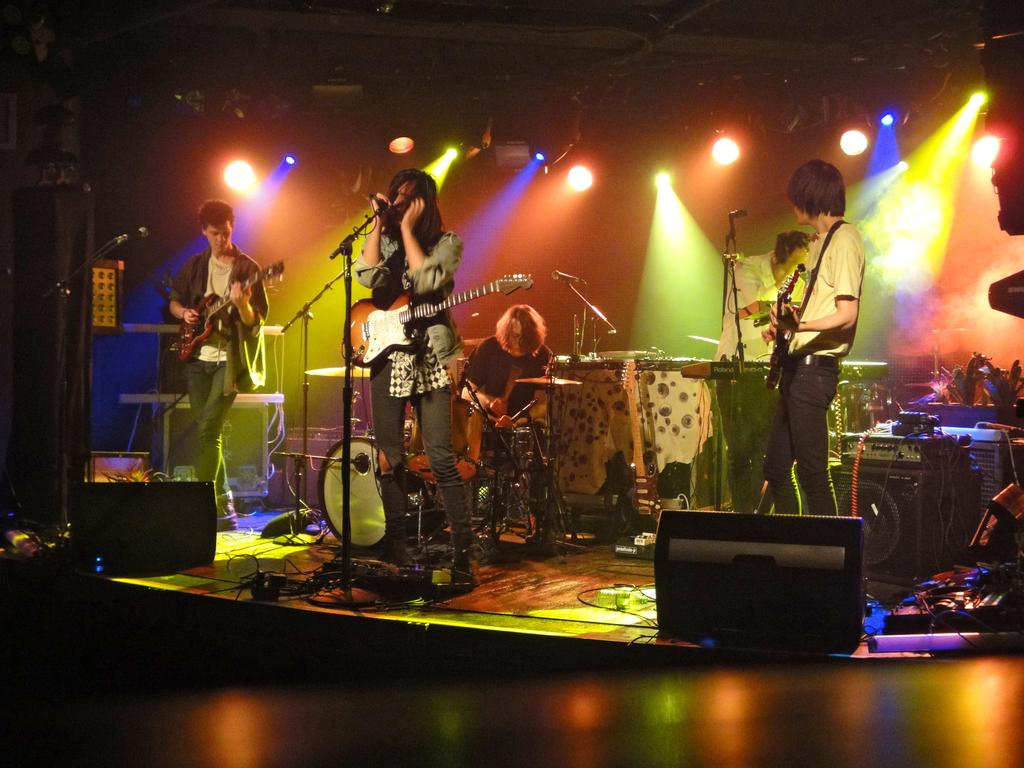What is happening in the image? There is a group of people in the image, and they are playing musical instruments. What is the role of the person in front of the microphone? One person is singing in front of a microphone. How many lizards can be seen in the scene? There are no lizards present in the image. What type of goat is featured in the background of the image? There is no goat present in the image. 